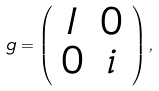Convert formula to latex. <formula><loc_0><loc_0><loc_500><loc_500>g = \left ( \begin{array} { c c } I & 0 \\ 0 & i \end{array} \right ) ,</formula> 